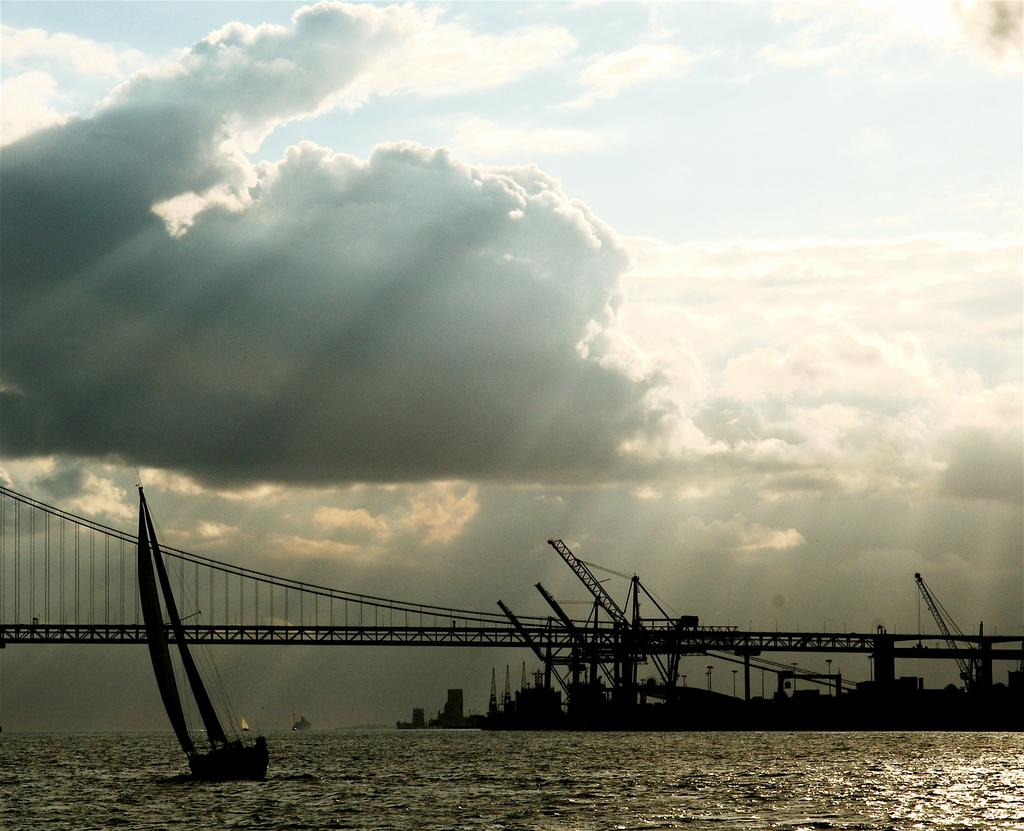What is the main feature of the image? The main feature of the image is a river with water. What is present in the river? There is a sailing boat in the river. What type of bridge can be seen in the image? There is an iron suspension bridge in the image. What can be found near the bridge? There are cranes near the bridge. What is visible in the background of the image? The sky is visible in the image, and white clouds are present in the sky. What type of protest is taking place near the river in the image? There is no protest present in the image; it features a river, a sailing boat, an iron suspension bridge, cranes, and a sky with white clouds. What kind of truck can be seen driving across the bridge in the image? There is no truck present in the image; it only features a sailing boat, an iron suspension bridge, cranes, and a sky with white clouds. 